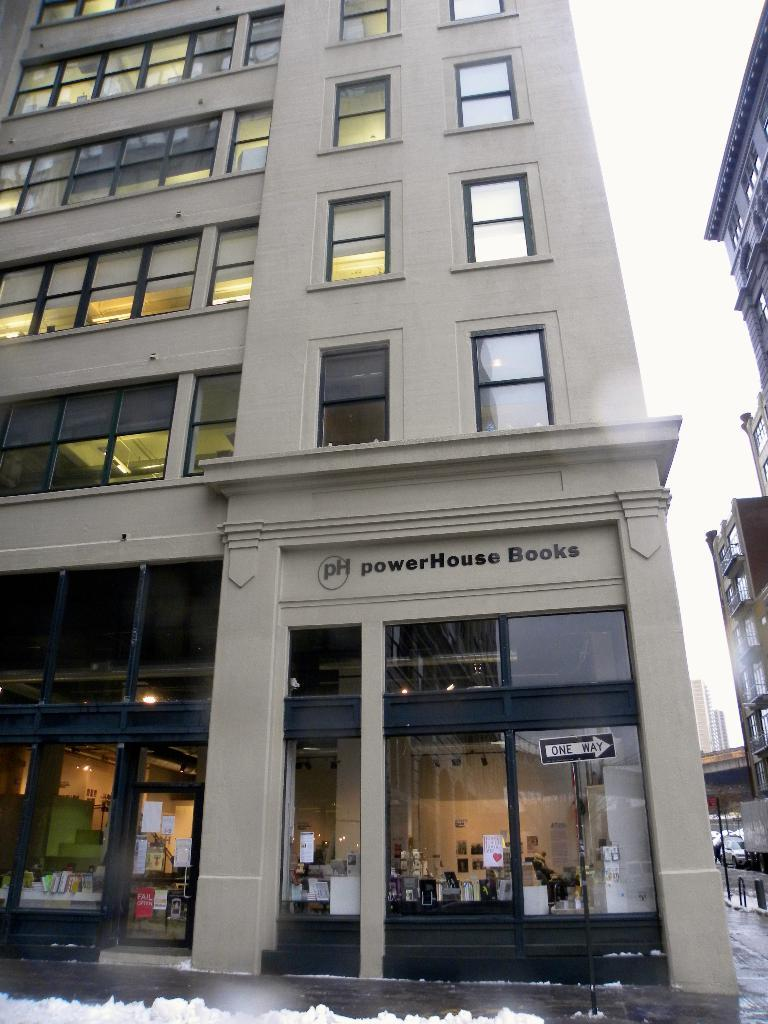What type of structures are present in the image? There are buildings in the image. What feature do the buildings have? The buildings have glass windows. What type of establishments can be found in the image? There are stores in the image. What feature do the stores have? The stores have glass doors. What vertical structures are visible in the image? There are poles in the image. What type of signage is present in the image? There is a signboard in the image. What weather condition is depicted in the image? The image shows snow. What is the color of the sky in the image? The sky is white in color. What type of popcorn is being sold in the stores in the image? There is no indication of popcorn being sold in the stores in the image. What type of twig can be seen in the image? There is no twig present in the image. 